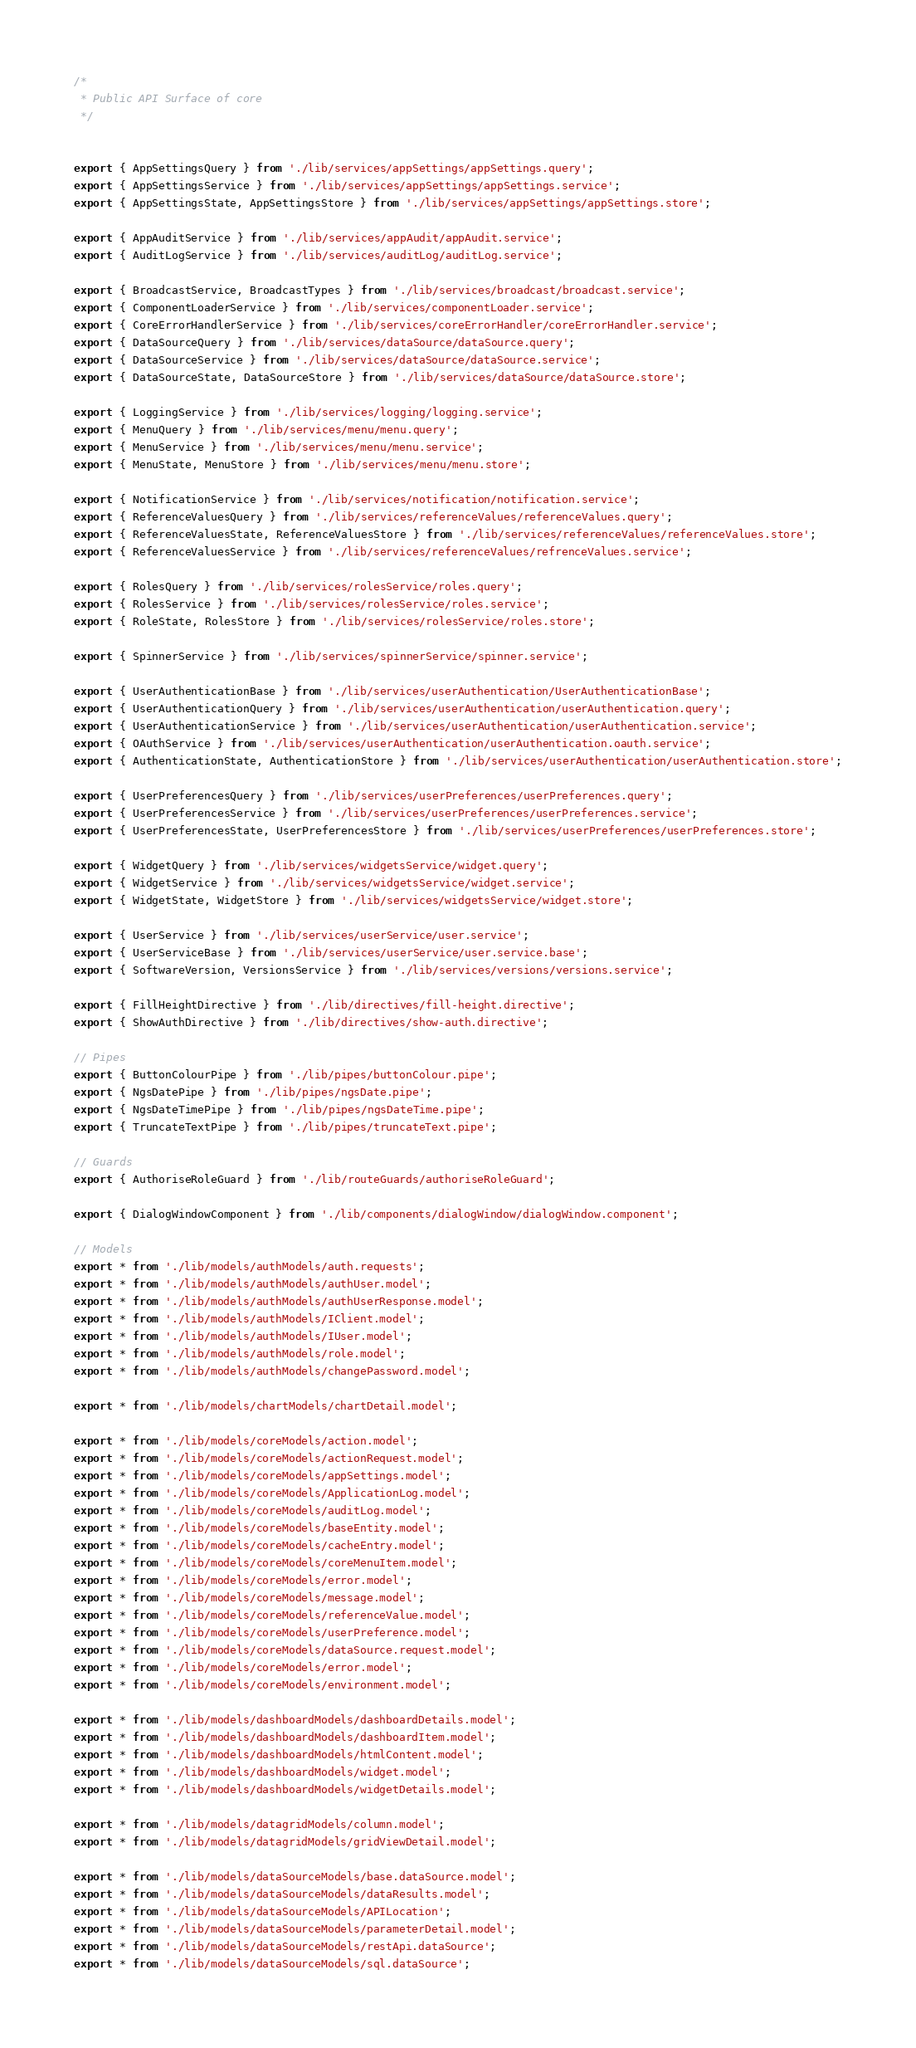Convert code to text. <code><loc_0><loc_0><loc_500><loc_500><_TypeScript_>/*
 * Public API Surface of core
 */


export { AppSettingsQuery } from './lib/services/appSettings/appSettings.query';
export { AppSettingsService } from './lib/services/appSettings/appSettings.service';
export { AppSettingsState, AppSettingsStore } from './lib/services/appSettings/appSettings.store';

export { AppAuditService } from './lib/services/appAudit/appAudit.service';
export { AuditLogService } from './lib/services/auditLog/auditLog.service';

export { BroadcastService, BroadcastTypes } from './lib/services/broadcast/broadcast.service';
export { ComponentLoaderService } from './lib/services/componentLoader.service';
export { CoreErrorHandlerService } from './lib/services/coreErrorHandler/coreErrorHandler.service';
export { DataSourceQuery } from './lib/services/dataSource/dataSource.query';
export { DataSourceService } from './lib/services/dataSource/dataSource.service';
export { DataSourceState, DataSourceStore } from './lib/services/dataSource/dataSource.store';

export { LoggingService } from './lib/services/logging/logging.service';
export { MenuQuery } from './lib/services/menu/menu.query';
export { MenuService } from './lib/services/menu/menu.service';
export { MenuState, MenuStore } from './lib/services/menu/menu.store';

export { NotificationService } from './lib/services/notification/notification.service';
export { ReferenceValuesQuery } from './lib/services/referenceValues/referenceValues.query';
export { ReferenceValuesState, ReferenceValuesStore } from './lib/services/referenceValues/referenceValues.store';
export { ReferenceValuesService } from './lib/services/referenceValues/refrenceValues.service';

export { RolesQuery } from './lib/services/rolesService/roles.query';
export { RolesService } from './lib/services/rolesService/roles.service';
export { RoleState, RolesStore } from './lib/services/rolesService/roles.store';

export { SpinnerService } from './lib/services/spinnerService/spinner.service';

export { UserAuthenticationBase } from './lib/services/userAuthentication/UserAuthenticationBase';
export { UserAuthenticationQuery } from './lib/services/userAuthentication/userAuthentication.query';
export { UserAuthenticationService } from './lib/services/userAuthentication/userAuthentication.service';
export { OAuthService } from './lib/services/userAuthentication/userAuthentication.oauth.service';
export { AuthenticationState, AuthenticationStore } from './lib/services/userAuthentication/userAuthentication.store';

export { UserPreferencesQuery } from './lib/services/userPreferences/userPreferences.query';
export { UserPreferencesService } from './lib/services/userPreferences/userPreferences.service';
export { UserPreferencesState, UserPreferencesStore } from './lib/services/userPreferences/userPreferences.store';

export { WidgetQuery } from './lib/services/widgetsService/widget.query';
export { WidgetService } from './lib/services/widgetsService/widget.service';
export { WidgetState, WidgetStore } from './lib/services/widgetsService/widget.store';

export { UserService } from './lib/services/userService/user.service';
export { UserServiceBase } from './lib/services/userService/user.service.base';
export { SoftwareVersion, VersionsService } from './lib/services/versions/versions.service';

export { FillHeightDirective } from './lib/directives/fill-height.directive';
export { ShowAuthDirective } from './lib/directives/show-auth.directive';

// Pipes
export { ButtonColourPipe } from './lib/pipes/buttonColour.pipe';
export { NgsDatePipe } from './lib/pipes/ngsDate.pipe';
export { NgsDateTimePipe } from './lib/pipes/ngsDateTime.pipe';
export { TruncateTextPipe } from './lib/pipes/truncateText.pipe';

// Guards
export { AuthoriseRoleGuard } from './lib/routeGuards/authoriseRoleGuard';

export { DialogWindowComponent } from './lib/components/dialogWindow/dialogWindow.component';

// Models
export * from './lib/models/authModels/auth.requests';
export * from './lib/models/authModels/authUser.model';
export * from './lib/models/authModels/authUserResponse.model';
export * from './lib/models/authModels/IClient.model';
export * from './lib/models/authModels/IUser.model';
export * from './lib/models/authModels/role.model';
export * from './lib/models/authModels/changePassword.model';

export * from './lib/models/chartModels/chartDetail.model';

export * from './lib/models/coreModels/action.model';
export * from './lib/models/coreModels/actionRequest.model';
export * from './lib/models/coreModels/appSettings.model';
export * from './lib/models/coreModels/ApplicationLog.model';
export * from './lib/models/coreModels/auditLog.model';
export * from './lib/models/coreModels/baseEntity.model';
export * from './lib/models/coreModels/cacheEntry.model';
export * from './lib/models/coreModels/coreMenuItem.model';
export * from './lib/models/coreModels/error.model';
export * from './lib/models/coreModels/message.model';
export * from './lib/models/coreModels/referenceValue.model';
export * from './lib/models/coreModels/userPreference.model';
export * from './lib/models/coreModels/dataSource.request.model';
export * from './lib/models/coreModels/error.model';
export * from './lib/models/coreModels/environment.model';

export * from './lib/models/dashboardModels/dashboardDetails.model';
export * from './lib/models/dashboardModels/dashboardItem.model';
export * from './lib/models/dashboardModels/htmlContent.model';
export * from './lib/models/dashboardModels/widget.model';
export * from './lib/models/dashboardModels/widgetDetails.model';

export * from './lib/models/datagridModels/column.model';
export * from './lib/models/datagridModels/gridViewDetail.model';

export * from './lib/models/dataSourceModels/base.dataSource.model';
export * from './lib/models/dataSourceModels/dataResults.model';
export * from './lib/models/dataSourceModels/APILocation';
export * from './lib/models/dataSourceModels/parameterDetail.model';
export * from './lib/models/dataSourceModels/restApi.dataSource';
export * from './lib/models/dataSourceModels/sql.dataSource';</code> 